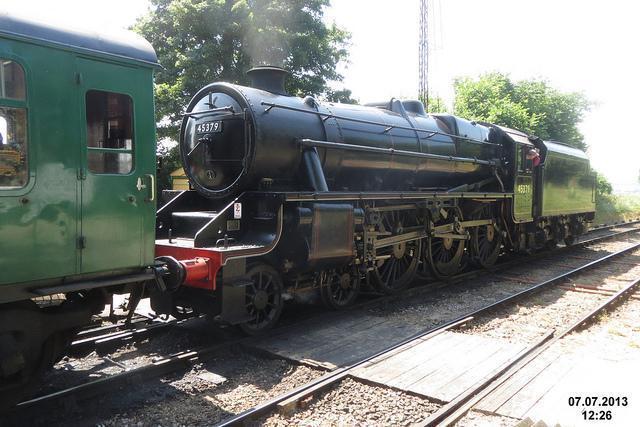Who invented this vehicle?
Indicate the correct response and explain using: 'Answer: answer
Rationale: rationale.'
Options: Richard trevithick, orville wright, jeff goldblum, bill nye. Answer: richard trevithick.
Rationale: Richard trevithick is the inventor of the train. 